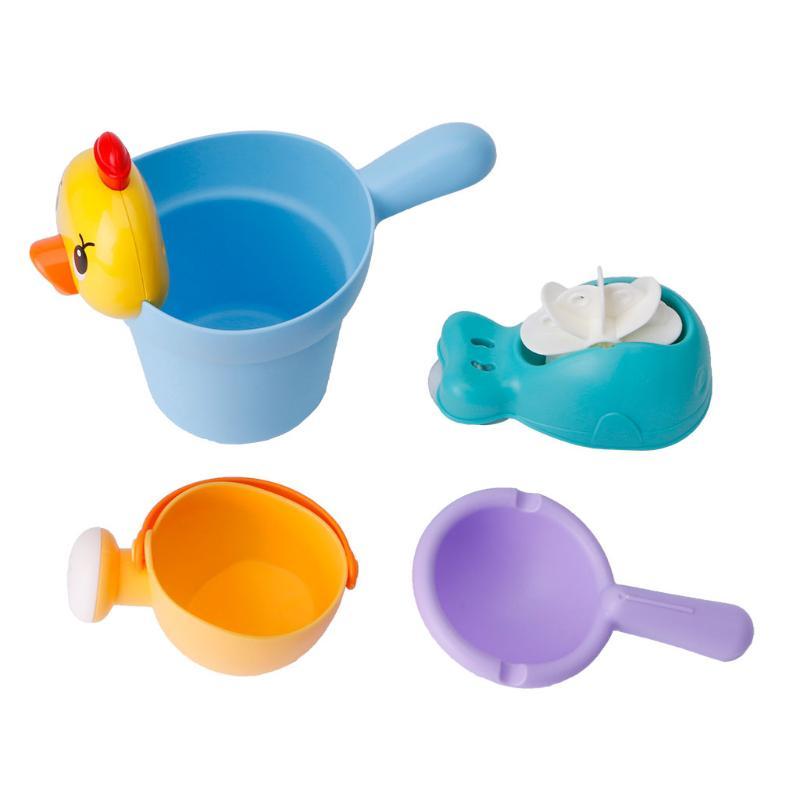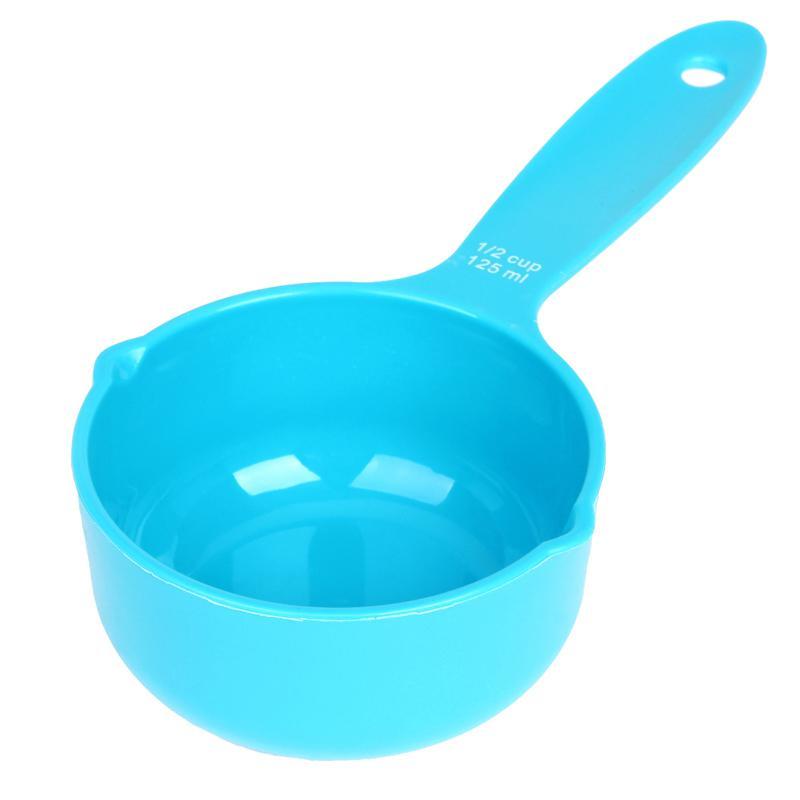The first image is the image on the left, the second image is the image on the right. Analyze the images presented: Is the assertion "An image includes a royal blue container with a white stripe and white spoon." valid? Answer yes or no. No. 